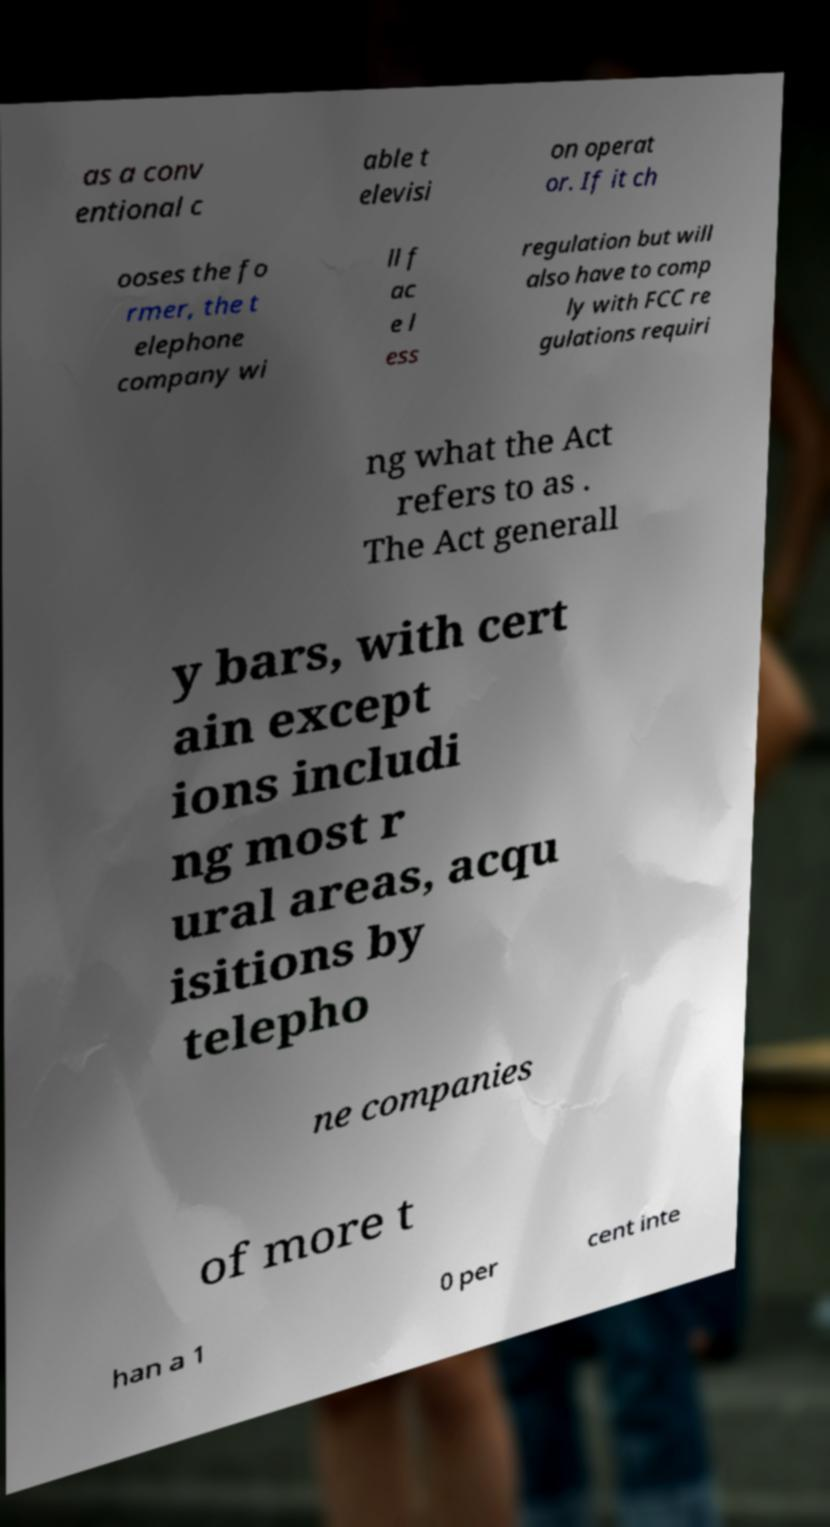Please identify and transcribe the text found in this image. as a conv entional c able t elevisi on operat or. If it ch ooses the fo rmer, the t elephone company wi ll f ac e l ess regulation but will also have to comp ly with FCC re gulations requiri ng what the Act refers to as . The Act generall y bars, with cert ain except ions includi ng most r ural areas, acqu isitions by telepho ne companies of more t han a 1 0 per cent inte 